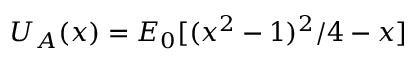Convert formula to latex. <formula><loc_0><loc_0><loc_500><loc_500>U _ { A } ( x ) = E _ { 0 } [ ( x ^ { 2 } - 1 ) ^ { 2 } / 4 - x ]</formula> 